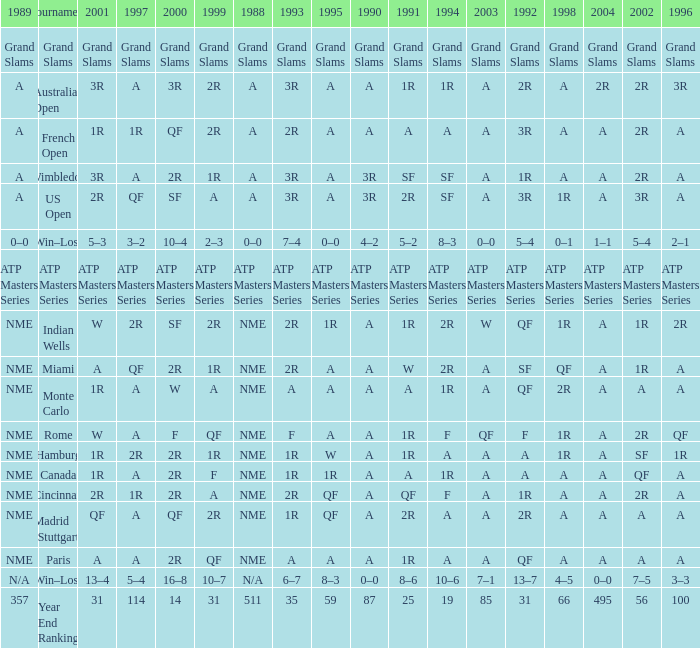What shows for 1992 when 1988 is A, at the Australian Open? 2R. 